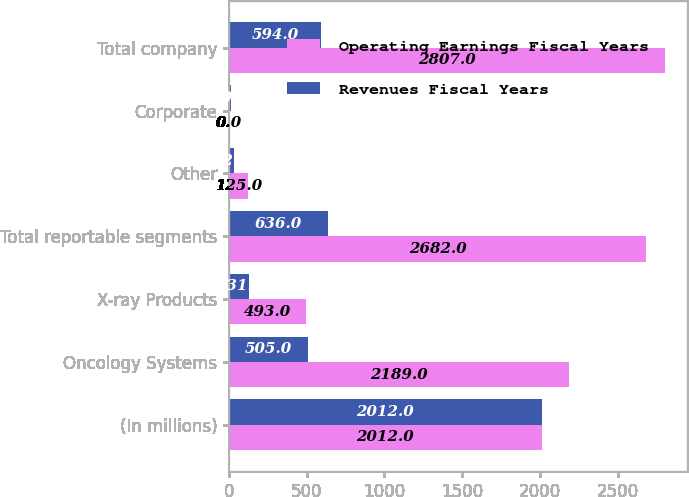<chart> <loc_0><loc_0><loc_500><loc_500><stacked_bar_chart><ecel><fcel>(In millions)<fcel>Oncology Systems<fcel>X-ray Products<fcel>Total reportable segments<fcel>Other<fcel>Corporate<fcel>Total company<nl><fcel>Operating Earnings Fiscal Years<fcel>2012<fcel>2189<fcel>493<fcel>2682<fcel>125<fcel>0<fcel>2807<nl><fcel>Revenues Fiscal Years<fcel>2012<fcel>505<fcel>131<fcel>636<fcel>32<fcel>10<fcel>594<nl></chart> 